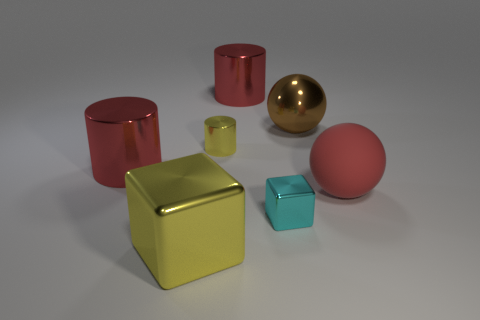What is the large cylinder that is right of the metallic block that is to the left of the tiny shiny thing in front of the yellow cylinder made of?
Your answer should be compact. Metal. Does the ball on the right side of the brown shiny ball have the same size as the red cylinder that is behind the small cylinder?
Make the answer very short. Yes. How many other things are there of the same material as the red sphere?
Provide a succinct answer. 0. How many rubber things are either tiny blue things or big cubes?
Keep it short and to the point. 0. Are there fewer big cylinders than purple metal cubes?
Your answer should be compact. No. Do the matte thing and the yellow shiny cylinder that is to the right of the big yellow shiny object have the same size?
Offer a terse response. No. How big is the brown object?
Keep it short and to the point. Large. Is the number of tiny blocks on the right side of the matte thing less than the number of green rubber cubes?
Your response must be concise. No. Do the yellow cube and the cyan metallic block have the same size?
Make the answer very short. No. What color is the small cylinder that is the same material as the brown sphere?
Provide a succinct answer. Yellow. 